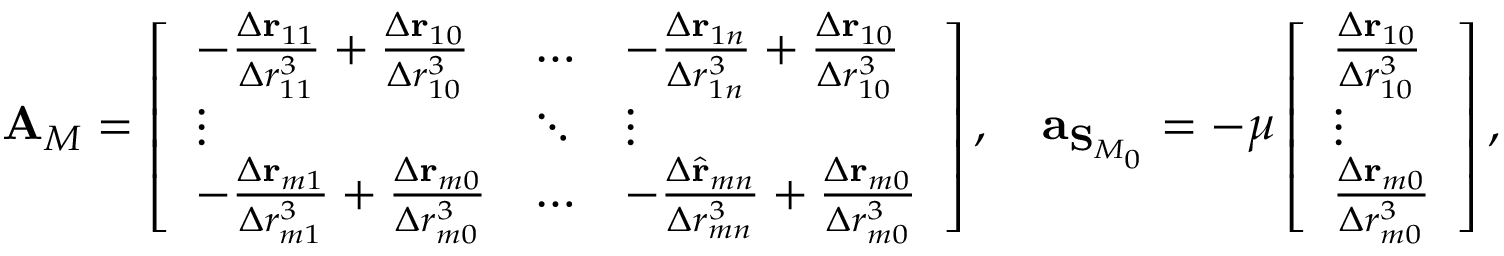Convert formula to latex. <formula><loc_0><loc_0><loc_500><loc_500>A _ { M } = \left [ \begin{array} { l l l } { - \frac { \Delta r _ { 1 1 } } { \Delta r _ { 1 1 } ^ { 3 } } + \frac { \Delta r _ { 1 0 } } { \Delta r _ { 1 0 } ^ { 3 } } } & { \hdots } & { - \frac { \Delta r _ { 1 n } } { \Delta r _ { 1 n } ^ { 3 } } + \frac { \Delta r _ { 1 0 } } { \Delta r _ { 1 0 } ^ { 3 } } } \\ { \vdots } & { \ddots } & { \vdots } \\ { - \frac { \Delta r _ { m 1 } } { \Delta r _ { m 1 } ^ { 3 } } + \frac { \Delta r _ { m 0 } } { \Delta r _ { m 0 } ^ { 3 } } } & { \hdots } & { - \frac { \Delta \hat { r } _ { m n } } { \Delta r _ { m n } ^ { 3 } } + \frac { \Delta r _ { m 0 } } { \Delta r _ { m 0 } ^ { 3 } } } \end{array} \right ] , \quad a _ { S _ { M _ { 0 } } } = - \mu \left [ \begin{array} { l } { \frac { \Delta r _ { 1 0 } } { \Delta r _ { 1 0 } ^ { 3 } } } \\ { \vdots } \\ { \frac { \Delta r _ { m 0 } } { \Delta r _ { m 0 } ^ { 3 } } } \end{array} \right ] ,</formula> 